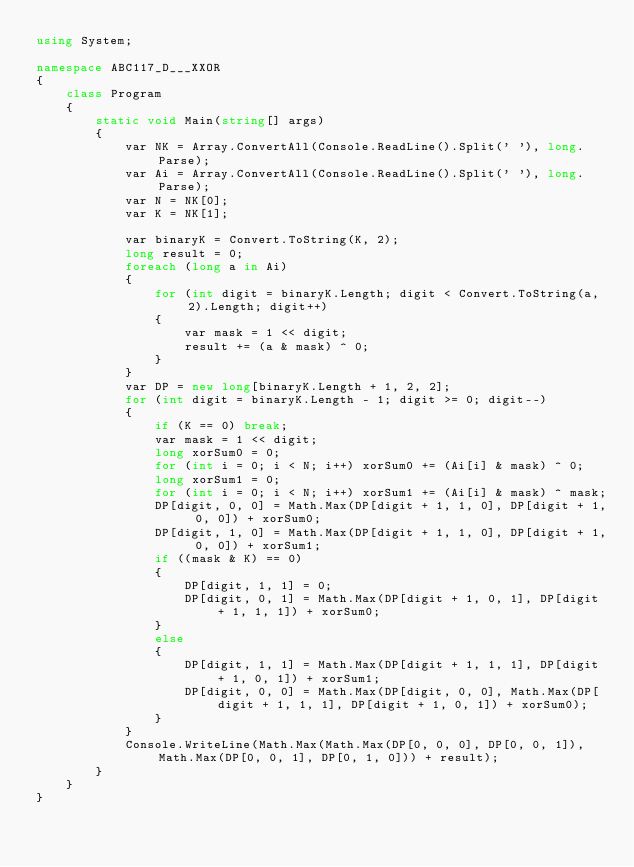<code> <loc_0><loc_0><loc_500><loc_500><_C#_>using System;

namespace ABC117_D___XXOR
{
    class Program
    {
        static void Main(string[] args)
        {
            var NK = Array.ConvertAll(Console.ReadLine().Split(' '), long.Parse);
            var Ai = Array.ConvertAll(Console.ReadLine().Split(' '), long.Parse);
            var N = NK[0];
            var K = NK[1];

            var binaryK = Convert.ToString(K, 2);
            long result = 0;
            foreach (long a in Ai)
            {
                for (int digit = binaryK.Length; digit < Convert.ToString(a, 2).Length; digit++)
                {
                    var mask = 1 << digit;
                    result += (a & mask) ^ 0;
                }
            }
            var DP = new long[binaryK.Length + 1, 2, 2];
            for (int digit = binaryK.Length - 1; digit >= 0; digit--)
            {
                if (K == 0) break;
                var mask = 1 << digit;
                long xorSum0 = 0;
                for (int i = 0; i < N; i++) xorSum0 += (Ai[i] & mask) ^ 0;
                long xorSum1 = 0;
                for (int i = 0; i < N; i++) xorSum1 += (Ai[i] & mask) ^ mask;
                DP[digit, 0, 0] = Math.Max(DP[digit + 1, 1, 0], DP[digit + 1, 0, 0]) + xorSum0;
                DP[digit, 1, 0] = Math.Max(DP[digit + 1, 1, 0], DP[digit + 1, 0, 0]) + xorSum1;
                if ((mask & K) == 0)
                {
                    DP[digit, 1, 1] = 0;
                    DP[digit, 0, 1] = Math.Max(DP[digit + 1, 0, 1], DP[digit + 1, 1, 1]) + xorSum0;
                }
                else
                {
                    DP[digit, 1, 1] = Math.Max(DP[digit + 1, 1, 1], DP[digit + 1, 0, 1]) + xorSum1;
                    DP[digit, 0, 0] = Math.Max(DP[digit, 0, 0], Math.Max(DP[digit + 1, 1, 1], DP[digit + 1, 0, 1]) + xorSum0);
                }
            }
            Console.WriteLine(Math.Max(Math.Max(DP[0, 0, 0], DP[0, 0, 1]), Math.Max(DP[0, 0, 1], DP[0, 1, 0])) + result);
        }
    }
}
</code> 